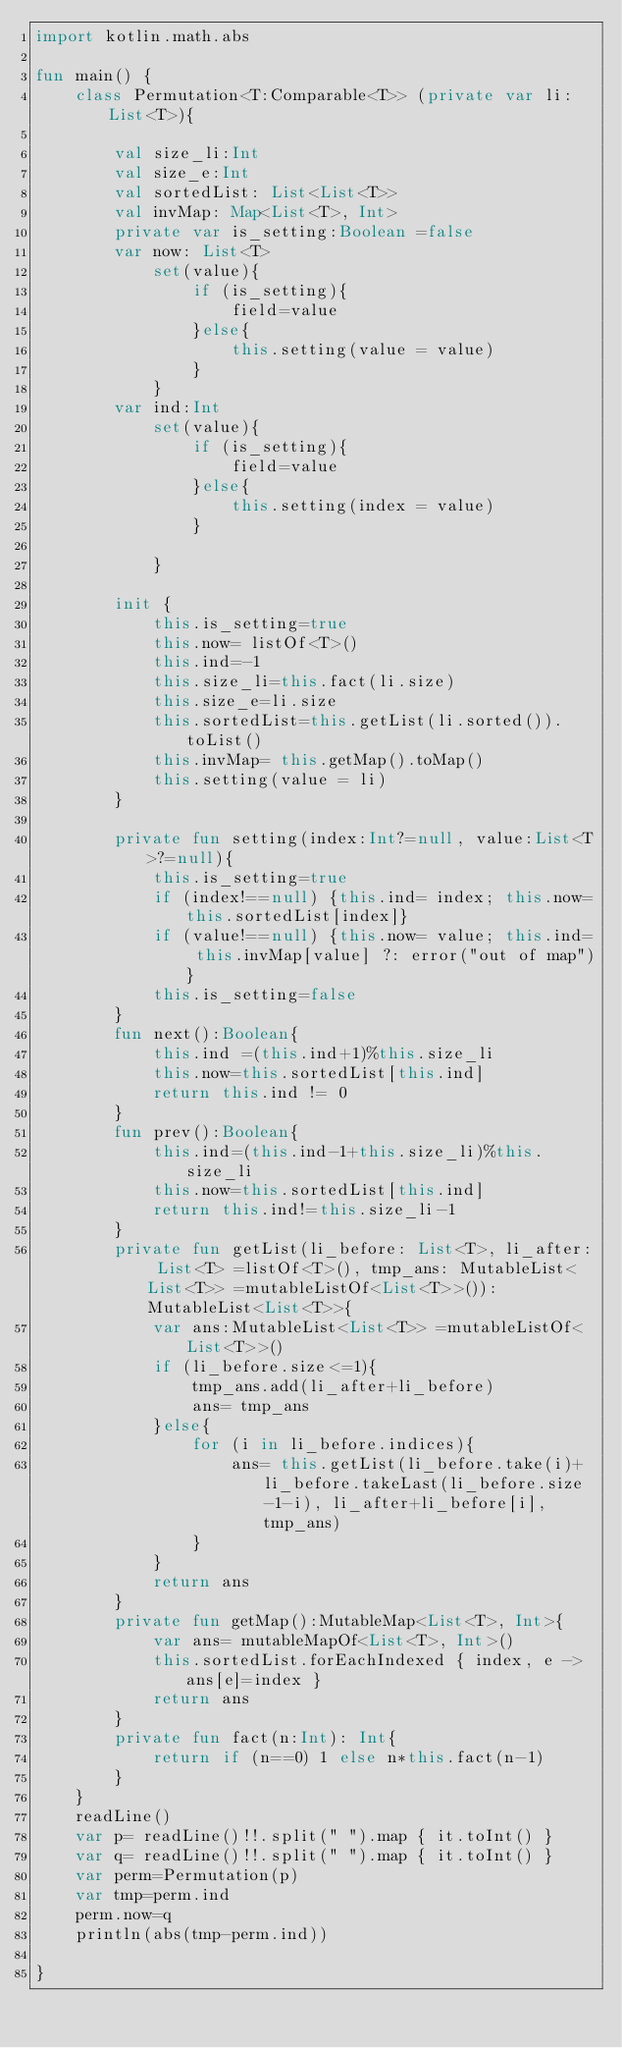<code> <loc_0><loc_0><loc_500><loc_500><_Kotlin_>import kotlin.math.abs

fun main() {
    class Permutation<T:Comparable<T>> (private var li: List<T>){

        val size_li:Int
        val size_e:Int
        val sortedList: List<List<T>>
        val invMap: Map<List<T>, Int>
        private var is_setting:Boolean =false
        var now: List<T>
            set(value){
                if (is_setting){
                    field=value
                }else{
                    this.setting(value = value)
                }
            }
        var ind:Int
            set(value){
                if (is_setting){
                    field=value
                }else{
                    this.setting(index = value)
                }

            }

        init {
            this.is_setting=true
            this.now= listOf<T>()
            this.ind=-1
            this.size_li=this.fact(li.size)
            this.size_e=li.size
            this.sortedList=this.getList(li.sorted()).toList()
            this.invMap= this.getMap().toMap()
            this.setting(value = li)
        }

        private fun setting(index:Int?=null, value:List<T>?=null){
            this.is_setting=true
            if (index!==null) {this.ind= index; this.now=this.sortedList[index]}
            if (value!==null) {this.now= value; this.ind= this.invMap[value] ?: error("out of map")}
            this.is_setting=false
        }
        fun next():Boolean{
            this.ind =(this.ind+1)%this.size_li
            this.now=this.sortedList[this.ind]
            return this.ind != 0
        }
        fun prev():Boolean{
            this.ind=(this.ind-1+this.size_li)%this.size_li
            this.now=this.sortedList[this.ind]
            return this.ind!=this.size_li-1
        }
        private fun getList(li_before: List<T>, li_after: List<T> =listOf<T>(), tmp_ans: MutableList<List<T>> =mutableListOf<List<T>>()): MutableList<List<T>>{
            var ans:MutableList<List<T>> =mutableListOf<List<T>>()
            if (li_before.size<=1){
                tmp_ans.add(li_after+li_before)
                ans= tmp_ans
            }else{
                for (i in li_before.indices){
                    ans= this.getList(li_before.take(i)+li_before.takeLast(li_before.size-1-i), li_after+li_before[i],tmp_ans)
                }
            }
            return ans
        }
        private fun getMap():MutableMap<List<T>, Int>{
            var ans= mutableMapOf<List<T>, Int>()
            this.sortedList.forEachIndexed { index, e -> ans[e]=index }
            return ans
        }
        private fun fact(n:Int): Int{
            return if (n==0) 1 else n*this.fact(n-1)
        }
    }
    readLine()
    var p= readLine()!!.split(" ").map { it.toInt() }
    var q= readLine()!!.split(" ").map { it.toInt() }
    var perm=Permutation(p)
    var tmp=perm.ind
    perm.now=q
    println(abs(tmp-perm.ind))

}</code> 